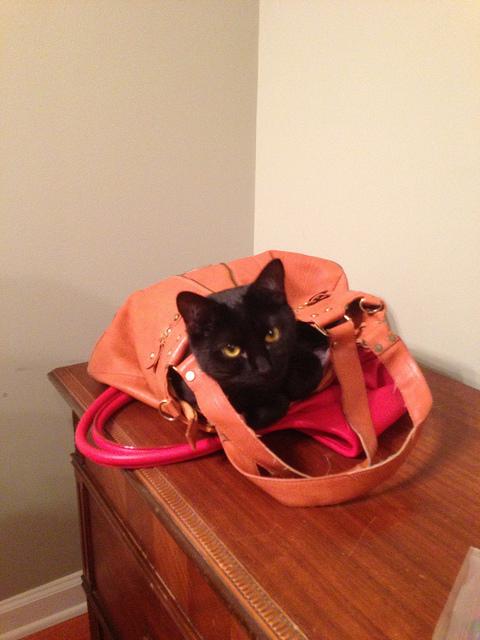Why is the cat in a bag?
Concise answer only. Hiding. Are the bags on the floor?
Keep it brief. No. How many handbags?
Write a very short answer. 2. 